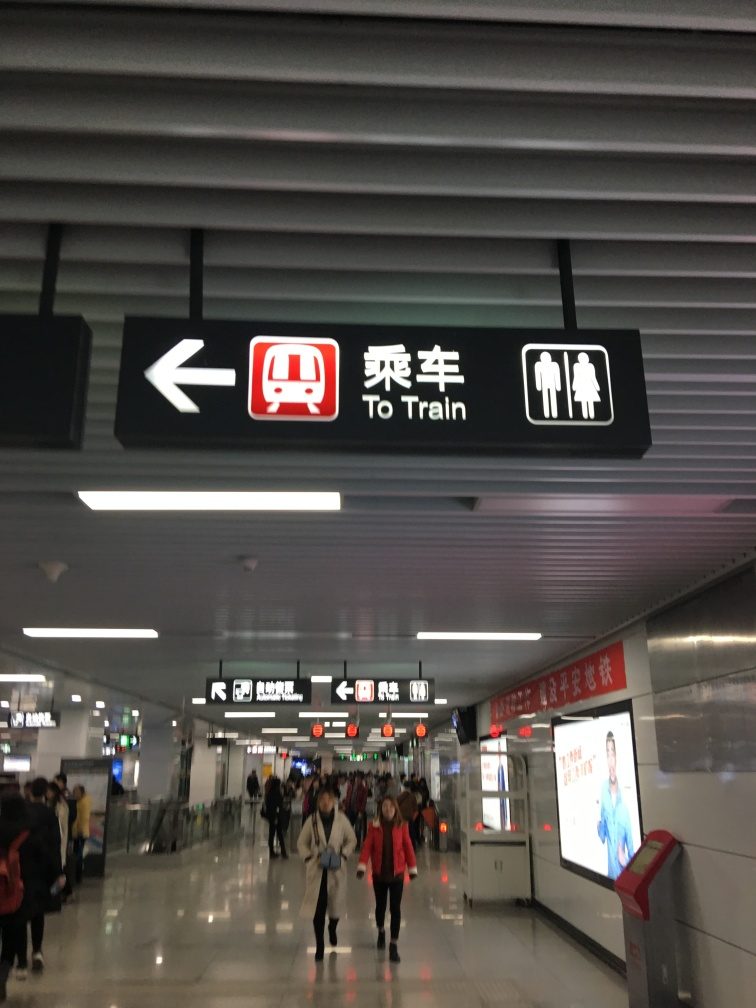Can you describe the setting of this image? Certainly! This image depicts an interior space likely within a public transportation hub, such as a metro or train station. Visible signage shows directions to the train and restrooms, a common requirement for wayfinding in such locations. The environment features fluorescent lighting and a modern, utilitarian design aesthetic, with passengers seemingly moving through the space, suggesting a photo taken at a non-peak hour due to the moderate crowd density. 